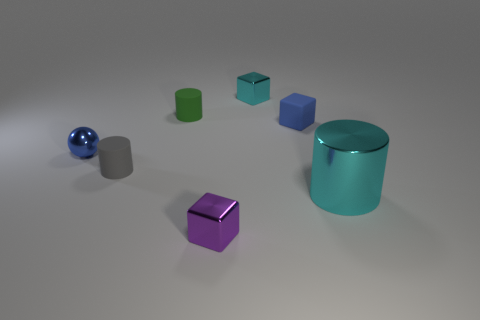Subtract all small cyan blocks. How many blocks are left? 2 Add 3 tiny brown metallic blocks. How many objects exist? 10 Subtract all gray cylinders. How many cylinders are left? 2 Subtract all cylinders. How many objects are left? 4 Subtract 2 blocks. How many blocks are left? 1 Subtract all small blue rubber cubes. Subtract all tiny blue balls. How many objects are left? 5 Add 6 tiny cyan blocks. How many tiny cyan blocks are left? 7 Add 7 big brown spheres. How many big brown spheres exist? 7 Subtract 0 green spheres. How many objects are left? 7 Subtract all green blocks. Subtract all yellow balls. How many blocks are left? 3 